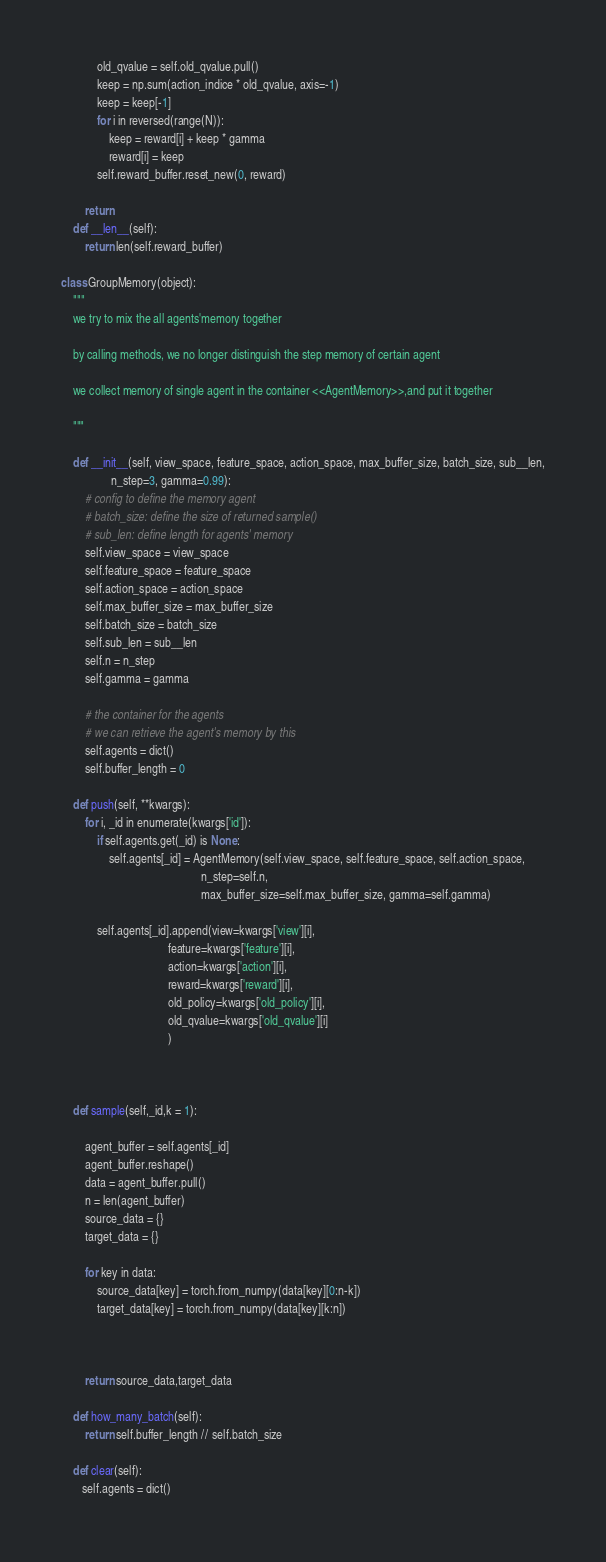<code> <loc_0><loc_0><loc_500><loc_500><_Python_>            old_qvalue = self.old_qvalue.pull()
            keep = np.sum(action_indice * old_qvalue, axis=-1)
            keep = keep[-1]
            for i in reversed(range(N)):
                keep = reward[i] + keep * gamma
                reward[i] = keep
            self.reward_buffer.reset_new(0, reward)

        return
    def __len__(self):
        return len(self.reward_buffer)

class GroupMemory(object):
    """
    we try to mix the all agents'memory together

    by calling methods, we no longer distinguish the step memory of certain agent

    we collect memory of single agent in the container <<AgentMemory>>,and put it together

    """

    def __init__(self, view_space, feature_space, action_space, max_buffer_size, batch_size, sub__len,
                 n_step=3, gamma=0.99):
        # config to define the memory agent
        # batch_size: define the size of returned sample()
        # sub_len: define length for agents' memory
        self.view_space = view_space
        self.feature_space = feature_space
        self.action_space = action_space
        self.max_buffer_size = max_buffer_size
        self.batch_size = batch_size
        self.sub_len = sub__len
        self.n = n_step
        self.gamma = gamma

        # the container for the agents
        # we can retrieve the agent's memory by this
        self.agents = dict()
        self.buffer_length = 0

    def push(self, **kwargs):
        for i, _id in enumerate(kwargs['id']):
            if self.agents.get(_id) is None:
                self.agents[_id] = AgentMemory(self.view_space, self.feature_space, self.action_space,
                                               n_step=self.n,
                                               max_buffer_size=self.max_buffer_size, gamma=self.gamma)

            self.agents[_id].append(view=kwargs['view'][i],
                                    feature=kwargs['feature'][i],
                                    action=kwargs['action'][i],
                                    reward=kwargs['reward'][i],
                                    old_policy=kwargs['old_policy'][i],
                                    old_qvalue=kwargs['old_qvalue'][i]
                                    )



    def sample(self,_id,k = 1):

        agent_buffer = self.agents[_id]
        agent_buffer.reshape()
        data = agent_buffer.pull()
        n = len(agent_buffer)
        source_data = {}
        target_data = {}

        for key in data:
            source_data[key] = torch.from_numpy(data[key][0:n-k])
            target_data[key] = torch.from_numpy(data[key][k:n])



        return source_data,target_data

    def how_many_batch(self):
        return self.buffer_length // self.batch_size

    def clear(self):
       self.agents = dict()

</code> 